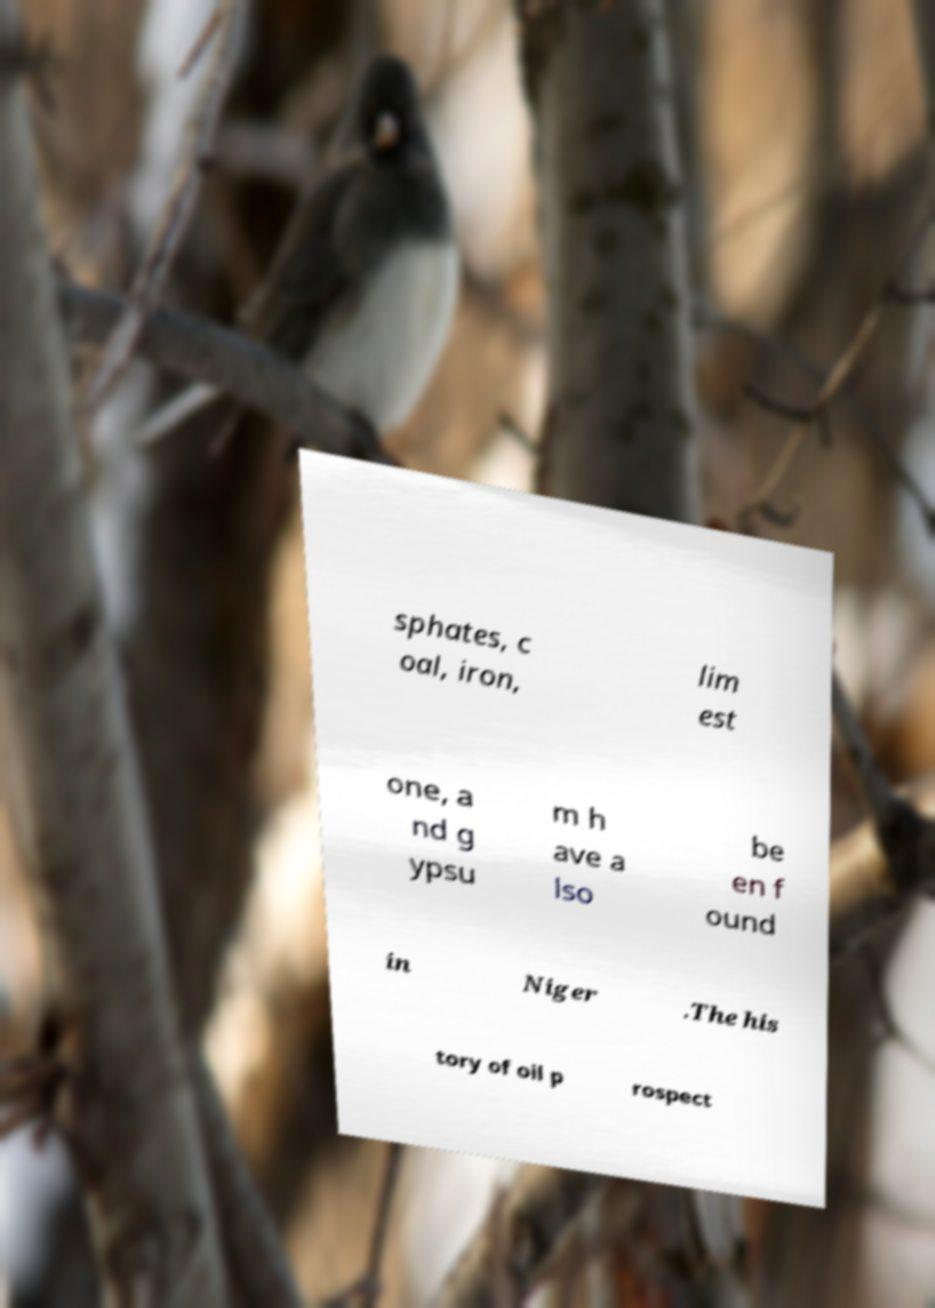Can you accurately transcribe the text from the provided image for me? sphates, c oal, iron, lim est one, a nd g ypsu m h ave a lso be en f ound in Niger .The his tory of oil p rospect 